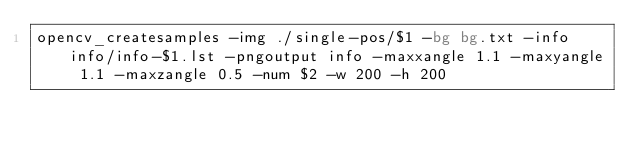Convert code to text. <code><loc_0><loc_0><loc_500><loc_500><_Bash_>opencv_createsamples -img ./single-pos/$1 -bg bg.txt -info info/info-$1.lst -pngoutput info -maxxangle 1.1 -maxyangle 1.1 -maxzangle 0.5 -num $2 -w 200 -h 200

</code> 